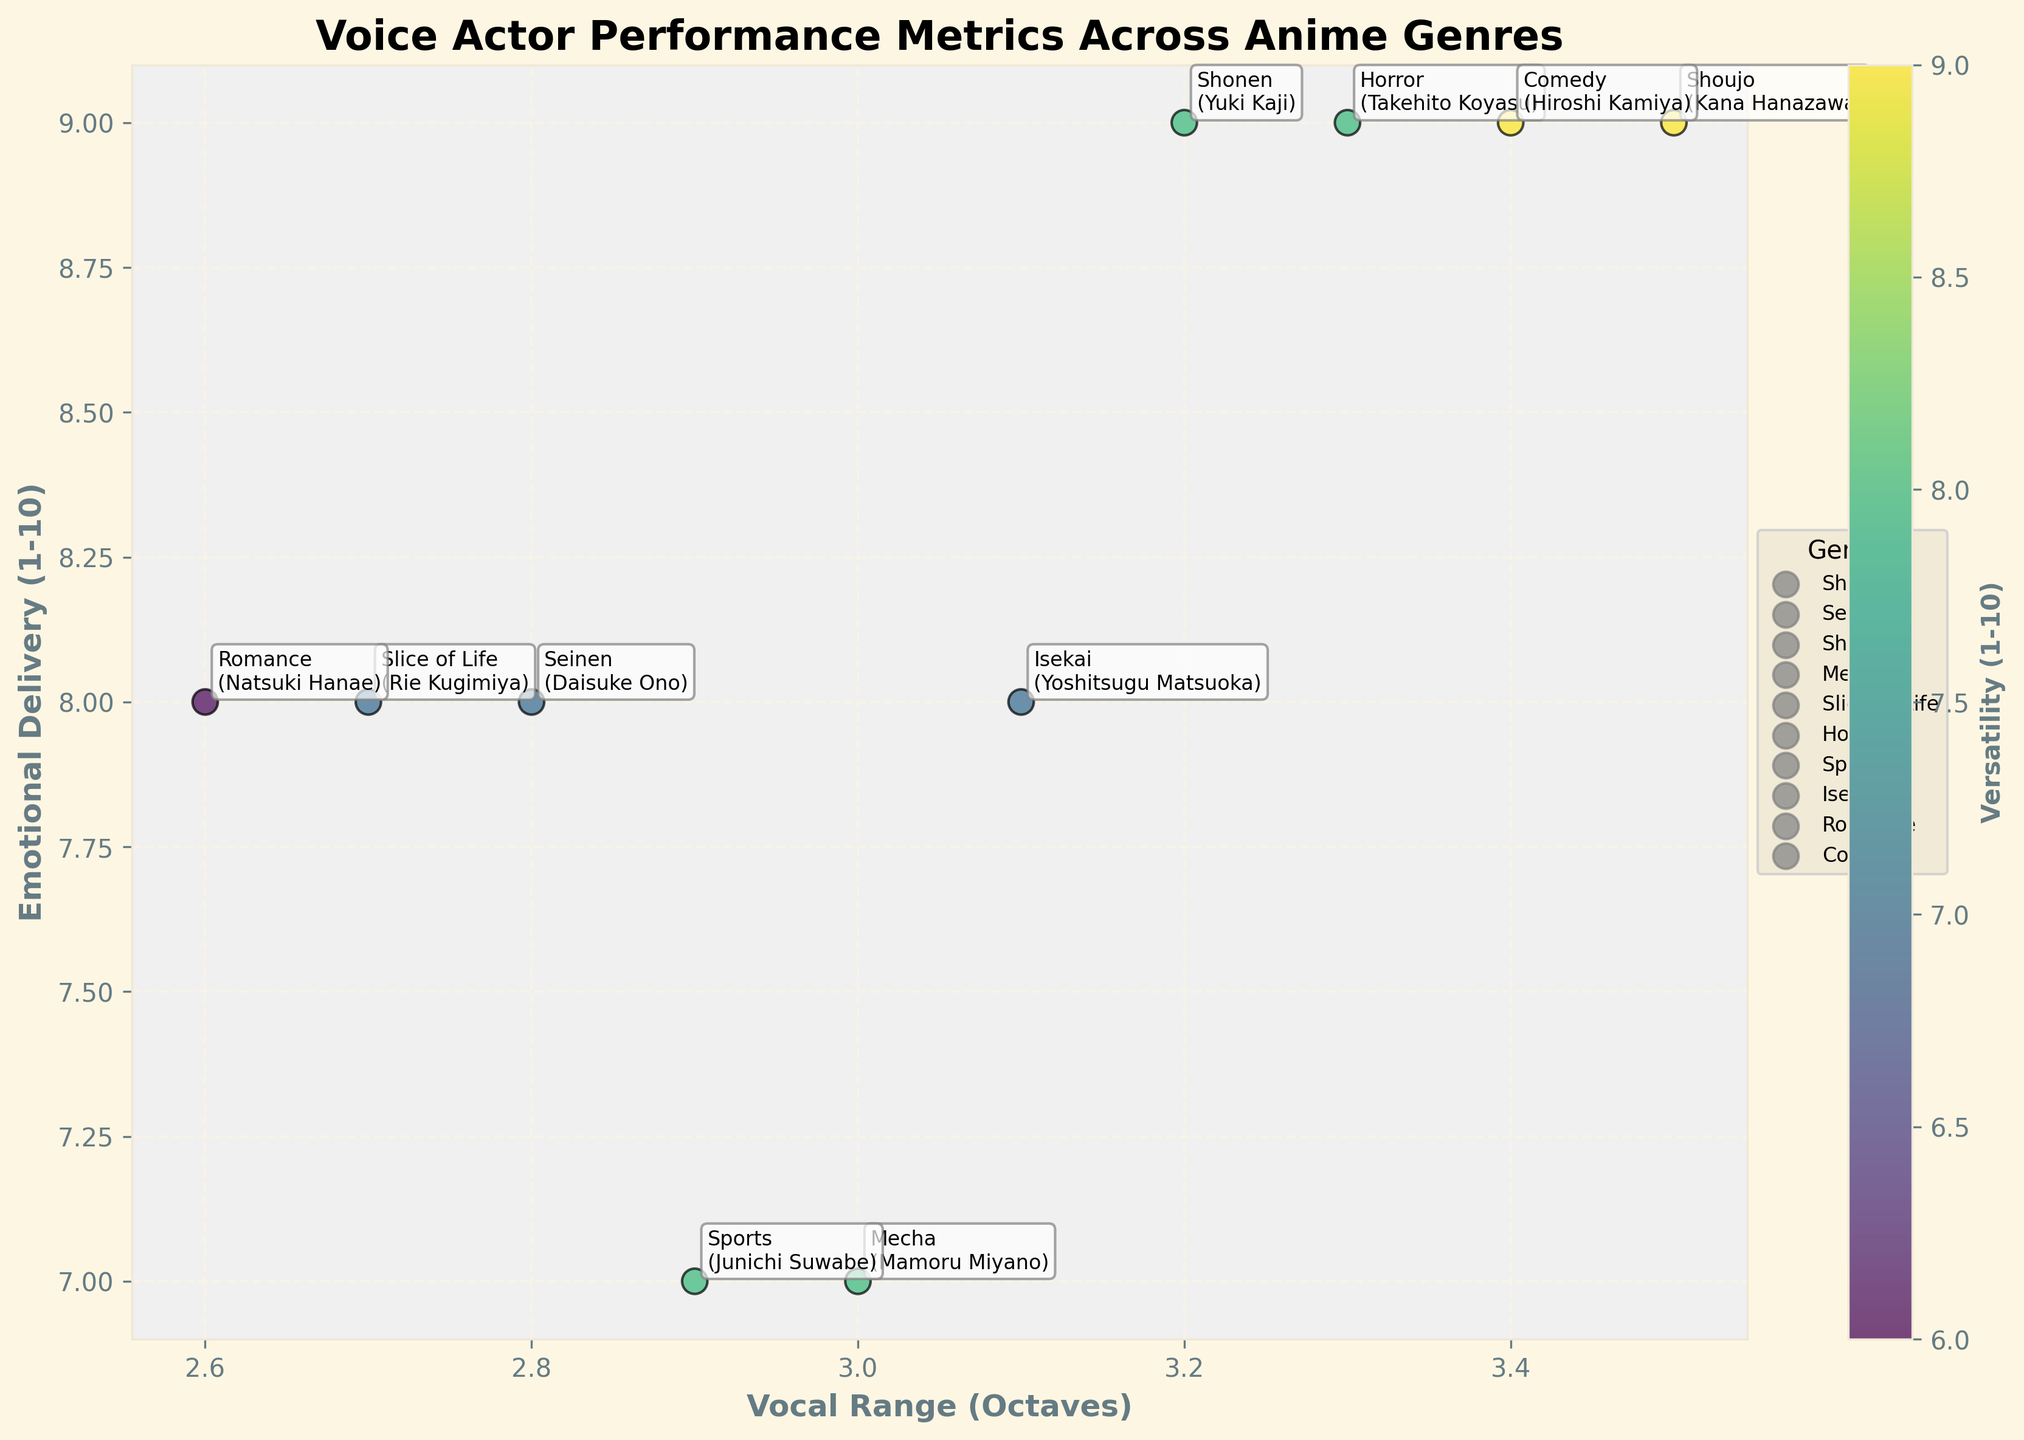What is the title of the figure? The title is located at the top of the figure, denoted in bold. It provides a summary of what the figure represents, which helps in understanding the context.
Answer: Voice Actor Performance Metrics Across Anime Genres Which voice actor has the highest vocal range? To find the actor with the highest vocal range, identify the data point with the highest x-axis value, then refer to the label associated with that point.
Answer: Kana Hanazawa How many data points are shown in the plot? Count the number of labeled data points in the scatter plot. Each point represents a voice actor corresponding to a different anime genre.
Answer: 10 Who has the same emotional delivery rating but different vocal range as Rie Kugimiya? First, identify Rie Kugimiya's emotional delivery rating on the y-axis, then check other data points with the same y-coordinate value. Look at the vocal range (x-axis) to confirm the differences.
Answer: Natsuki Hanae Which genre does the voice actor with the highest versatility belong to? Look at the color legend which represents versatility on a color scale. Find the brightest or most vibrant color corresponding to the highest versatility, and read the genre label next to it.
Answer: Shoujo (Kana Hanazawa) and Comedy (Hiroshi Kamiya) What is the difference in vocal range between Takehito Koyasu and Mamoru Miyano? Locate the vocal range of Takehito Koyasu and Mamoru Miyano on the x-axis. Subtract the smaller range from the larger range to find the difference. Takehito has a range of 3.3 octaves and Mamoru has 3.0 octaves.
Answer: 0.3 octaves Who are the voice actors with an emotional delivery rating of 9? Identify the points on the y-axis corresponding to a value of 9. Check the labels attached to these points for the names.
Answer: Yuki Kaji, Kana Hanazawa, Takehito Koyasu, Hiroshi Kamiya What is the average versatility rating of actors in genres with an emotional delivery score of 8? Identify data points where the y-axis value is 8. Sum their versatility ratings (Daisuke Ono, Rie Kugimiya, Yoshitsugu Matsuoka, Natsuki Hanae) and divide by the number of data points. (7 + 7 + 7 + 6)/4 = 6.75
Answer: 6.75 Which actor has higher versatility: Mamoru Miyano or Junichi Suwabe? Identify and compare the versatility ratings indicated by color for Mamoru Miyano and Junichi Suwabe.
Answer: Neither, both have the same versatility rating (8) How does vocal range correlate with emotional delivery for the actors shown? Look for the overall trend by examining the scatter plot's point distribution. Determine if there's a noticeable pattern where higher/lower vocal range matches higher/lower emotional delivery.
Answer: There seems to be no strong correlation 